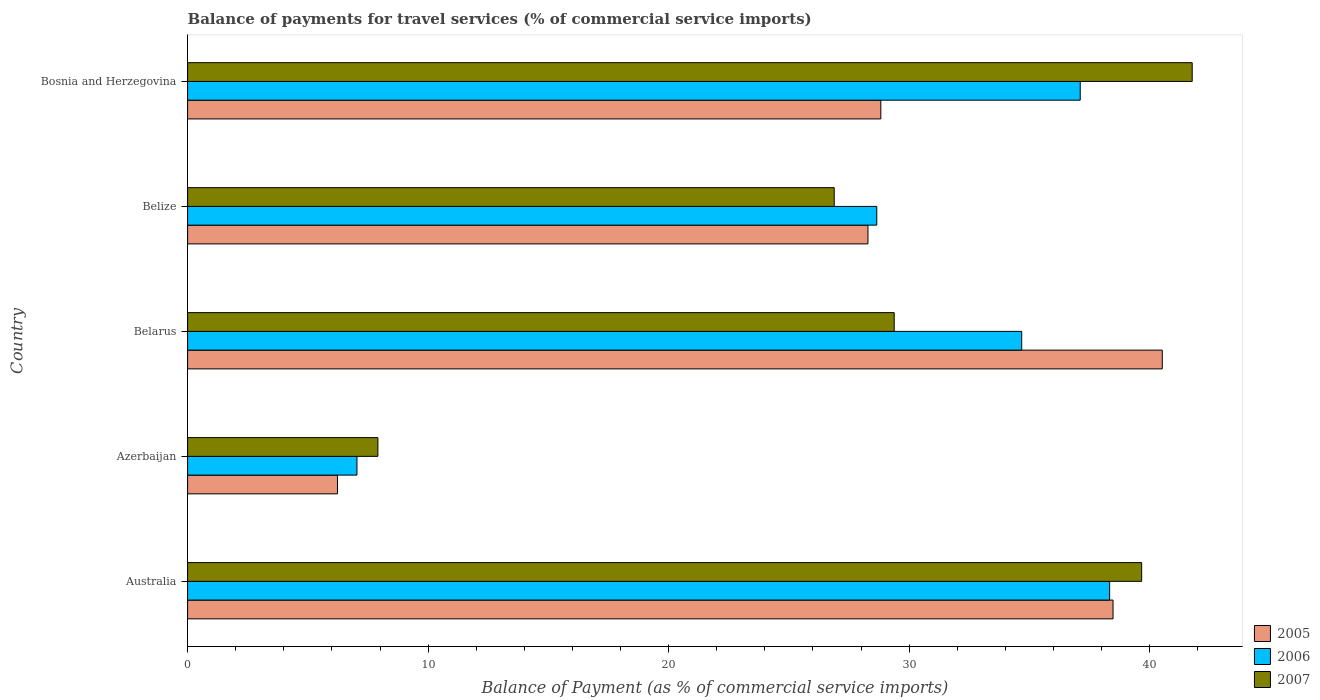How many different coloured bars are there?
Make the answer very short. 3. How many groups of bars are there?
Provide a succinct answer. 5. Are the number of bars on each tick of the Y-axis equal?
Give a very brief answer. Yes. How many bars are there on the 3rd tick from the top?
Your answer should be compact. 3. How many bars are there on the 4th tick from the bottom?
Provide a short and direct response. 3. What is the label of the 4th group of bars from the top?
Make the answer very short. Azerbaijan. What is the balance of payments for travel services in 2005 in Bosnia and Herzegovina?
Your answer should be compact. 28.82. Across all countries, what is the maximum balance of payments for travel services in 2006?
Keep it short and to the point. 38.34. Across all countries, what is the minimum balance of payments for travel services in 2007?
Your answer should be very brief. 7.91. In which country was the balance of payments for travel services in 2005 maximum?
Give a very brief answer. Belarus. In which country was the balance of payments for travel services in 2006 minimum?
Your response must be concise. Azerbaijan. What is the total balance of payments for travel services in 2005 in the graph?
Offer a very short reply. 142.35. What is the difference between the balance of payments for travel services in 2007 in Australia and that in Belarus?
Make the answer very short. 10.29. What is the difference between the balance of payments for travel services in 2007 in Belize and the balance of payments for travel services in 2005 in Bosnia and Herzegovina?
Your response must be concise. -1.94. What is the average balance of payments for travel services in 2005 per country?
Ensure brevity in your answer.  28.47. What is the difference between the balance of payments for travel services in 2005 and balance of payments for travel services in 2006 in Australia?
Your answer should be compact. 0.14. What is the ratio of the balance of payments for travel services in 2005 in Australia to that in Azerbaijan?
Offer a very short reply. 6.17. Is the difference between the balance of payments for travel services in 2005 in Belarus and Bosnia and Herzegovina greater than the difference between the balance of payments for travel services in 2006 in Belarus and Bosnia and Herzegovina?
Keep it short and to the point. Yes. What is the difference between the highest and the second highest balance of payments for travel services in 2006?
Offer a terse response. 1.22. What is the difference between the highest and the lowest balance of payments for travel services in 2006?
Your response must be concise. 31.3. What does the 1st bar from the top in Belarus represents?
Ensure brevity in your answer.  2007. Is it the case that in every country, the sum of the balance of payments for travel services in 2006 and balance of payments for travel services in 2005 is greater than the balance of payments for travel services in 2007?
Keep it short and to the point. Yes. How many bars are there?
Keep it short and to the point. 15. Are all the bars in the graph horizontal?
Your answer should be compact. Yes. What is the difference between two consecutive major ticks on the X-axis?
Your answer should be compact. 10. Does the graph contain grids?
Make the answer very short. No. How many legend labels are there?
Provide a succinct answer. 3. How are the legend labels stacked?
Ensure brevity in your answer.  Vertical. What is the title of the graph?
Provide a short and direct response. Balance of payments for travel services (% of commercial service imports). What is the label or title of the X-axis?
Your response must be concise. Balance of Payment (as % of commercial service imports). What is the label or title of the Y-axis?
Make the answer very short. Country. What is the Balance of Payment (as % of commercial service imports) of 2005 in Australia?
Your response must be concise. 38.48. What is the Balance of Payment (as % of commercial service imports) in 2006 in Australia?
Give a very brief answer. 38.34. What is the Balance of Payment (as % of commercial service imports) of 2007 in Australia?
Make the answer very short. 39.67. What is the Balance of Payment (as % of commercial service imports) in 2005 in Azerbaijan?
Give a very brief answer. 6.23. What is the Balance of Payment (as % of commercial service imports) of 2006 in Azerbaijan?
Your answer should be very brief. 7.04. What is the Balance of Payment (as % of commercial service imports) of 2007 in Azerbaijan?
Make the answer very short. 7.91. What is the Balance of Payment (as % of commercial service imports) in 2005 in Belarus?
Provide a short and direct response. 40.53. What is the Balance of Payment (as % of commercial service imports) of 2006 in Belarus?
Your answer should be compact. 34.68. What is the Balance of Payment (as % of commercial service imports) of 2007 in Belarus?
Ensure brevity in your answer.  29.38. What is the Balance of Payment (as % of commercial service imports) of 2005 in Belize?
Give a very brief answer. 28.29. What is the Balance of Payment (as % of commercial service imports) in 2006 in Belize?
Make the answer very short. 28.66. What is the Balance of Payment (as % of commercial service imports) in 2007 in Belize?
Your response must be concise. 26.89. What is the Balance of Payment (as % of commercial service imports) in 2005 in Bosnia and Herzegovina?
Give a very brief answer. 28.82. What is the Balance of Payment (as % of commercial service imports) of 2006 in Bosnia and Herzegovina?
Give a very brief answer. 37.12. What is the Balance of Payment (as % of commercial service imports) in 2007 in Bosnia and Herzegovina?
Give a very brief answer. 41.77. Across all countries, what is the maximum Balance of Payment (as % of commercial service imports) of 2005?
Give a very brief answer. 40.53. Across all countries, what is the maximum Balance of Payment (as % of commercial service imports) of 2006?
Offer a terse response. 38.34. Across all countries, what is the maximum Balance of Payment (as % of commercial service imports) in 2007?
Your response must be concise. 41.77. Across all countries, what is the minimum Balance of Payment (as % of commercial service imports) in 2005?
Your answer should be very brief. 6.23. Across all countries, what is the minimum Balance of Payment (as % of commercial service imports) of 2006?
Provide a short and direct response. 7.04. Across all countries, what is the minimum Balance of Payment (as % of commercial service imports) in 2007?
Offer a very short reply. 7.91. What is the total Balance of Payment (as % of commercial service imports) in 2005 in the graph?
Provide a short and direct response. 142.35. What is the total Balance of Payment (as % of commercial service imports) of 2006 in the graph?
Your response must be concise. 145.83. What is the total Balance of Payment (as % of commercial service imports) of 2007 in the graph?
Your response must be concise. 145.62. What is the difference between the Balance of Payment (as % of commercial service imports) of 2005 in Australia and that in Azerbaijan?
Your answer should be compact. 32.25. What is the difference between the Balance of Payment (as % of commercial service imports) in 2006 in Australia and that in Azerbaijan?
Offer a very short reply. 31.3. What is the difference between the Balance of Payment (as % of commercial service imports) in 2007 in Australia and that in Azerbaijan?
Make the answer very short. 31.76. What is the difference between the Balance of Payment (as % of commercial service imports) in 2005 in Australia and that in Belarus?
Your answer should be very brief. -2.05. What is the difference between the Balance of Payment (as % of commercial service imports) in 2006 in Australia and that in Belarus?
Provide a short and direct response. 3.66. What is the difference between the Balance of Payment (as % of commercial service imports) in 2007 in Australia and that in Belarus?
Offer a very short reply. 10.29. What is the difference between the Balance of Payment (as % of commercial service imports) of 2005 in Australia and that in Belize?
Offer a very short reply. 10.19. What is the difference between the Balance of Payment (as % of commercial service imports) of 2006 in Australia and that in Belize?
Provide a short and direct response. 9.68. What is the difference between the Balance of Payment (as % of commercial service imports) of 2007 in Australia and that in Belize?
Offer a very short reply. 12.78. What is the difference between the Balance of Payment (as % of commercial service imports) in 2005 in Australia and that in Bosnia and Herzegovina?
Make the answer very short. 9.65. What is the difference between the Balance of Payment (as % of commercial service imports) in 2006 in Australia and that in Bosnia and Herzegovina?
Offer a very short reply. 1.22. What is the difference between the Balance of Payment (as % of commercial service imports) in 2007 in Australia and that in Bosnia and Herzegovina?
Keep it short and to the point. -2.1. What is the difference between the Balance of Payment (as % of commercial service imports) in 2005 in Azerbaijan and that in Belarus?
Give a very brief answer. -34.3. What is the difference between the Balance of Payment (as % of commercial service imports) of 2006 in Azerbaijan and that in Belarus?
Offer a terse response. -27.64. What is the difference between the Balance of Payment (as % of commercial service imports) of 2007 in Azerbaijan and that in Belarus?
Make the answer very short. -21.47. What is the difference between the Balance of Payment (as % of commercial service imports) of 2005 in Azerbaijan and that in Belize?
Offer a very short reply. -22.06. What is the difference between the Balance of Payment (as % of commercial service imports) of 2006 in Azerbaijan and that in Belize?
Your answer should be very brief. -21.61. What is the difference between the Balance of Payment (as % of commercial service imports) in 2007 in Azerbaijan and that in Belize?
Offer a terse response. -18.97. What is the difference between the Balance of Payment (as % of commercial service imports) in 2005 in Azerbaijan and that in Bosnia and Herzegovina?
Give a very brief answer. -22.59. What is the difference between the Balance of Payment (as % of commercial service imports) in 2006 in Azerbaijan and that in Bosnia and Herzegovina?
Your response must be concise. -30.07. What is the difference between the Balance of Payment (as % of commercial service imports) in 2007 in Azerbaijan and that in Bosnia and Herzegovina?
Your answer should be very brief. -33.86. What is the difference between the Balance of Payment (as % of commercial service imports) in 2005 in Belarus and that in Belize?
Provide a short and direct response. 12.24. What is the difference between the Balance of Payment (as % of commercial service imports) in 2006 in Belarus and that in Belize?
Provide a short and direct response. 6.03. What is the difference between the Balance of Payment (as % of commercial service imports) of 2007 in Belarus and that in Belize?
Provide a succinct answer. 2.49. What is the difference between the Balance of Payment (as % of commercial service imports) of 2005 in Belarus and that in Bosnia and Herzegovina?
Keep it short and to the point. 11.7. What is the difference between the Balance of Payment (as % of commercial service imports) in 2006 in Belarus and that in Bosnia and Herzegovina?
Make the answer very short. -2.43. What is the difference between the Balance of Payment (as % of commercial service imports) in 2007 in Belarus and that in Bosnia and Herzegovina?
Your answer should be compact. -12.39. What is the difference between the Balance of Payment (as % of commercial service imports) of 2005 in Belize and that in Bosnia and Herzegovina?
Provide a succinct answer. -0.53. What is the difference between the Balance of Payment (as % of commercial service imports) of 2006 in Belize and that in Bosnia and Herzegovina?
Offer a very short reply. -8.46. What is the difference between the Balance of Payment (as % of commercial service imports) of 2007 in Belize and that in Bosnia and Herzegovina?
Ensure brevity in your answer.  -14.88. What is the difference between the Balance of Payment (as % of commercial service imports) of 2005 in Australia and the Balance of Payment (as % of commercial service imports) of 2006 in Azerbaijan?
Give a very brief answer. 31.44. What is the difference between the Balance of Payment (as % of commercial service imports) of 2005 in Australia and the Balance of Payment (as % of commercial service imports) of 2007 in Azerbaijan?
Give a very brief answer. 30.57. What is the difference between the Balance of Payment (as % of commercial service imports) of 2006 in Australia and the Balance of Payment (as % of commercial service imports) of 2007 in Azerbaijan?
Make the answer very short. 30.43. What is the difference between the Balance of Payment (as % of commercial service imports) in 2005 in Australia and the Balance of Payment (as % of commercial service imports) in 2006 in Belarus?
Your answer should be compact. 3.8. What is the difference between the Balance of Payment (as % of commercial service imports) of 2005 in Australia and the Balance of Payment (as % of commercial service imports) of 2007 in Belarus?
Make the answer very short. 9.1. What is the difference between the Balance of Payment (as % of commercial service imports) of 2006 in Australia and the Balance of Payment (as % of commercial service imports) of 2007 in Belarus?
Keep it short and to the point. 8.96. What is the difference between the Balance of Payment (as % of commercial service imports) of 2005 in Australia and the Balance of Payment (as % of commercial service imports) of 2006 in Belize?
Your answer should be compact. 9.82. What is the difference between the Balance of Payment (as % of commercial service imports) in 2005 in Australia and the Balance of Payment (as % of commercial service imports) in 2007 in Belize?
Provide a short and direct response. 11.59. What is the difference between the Balance of Payment (as % of commercial service imports) in 2006 in Australia and the Balance of Payment (as % of commercial service imports) in 2007 in Belize?
Provide a succinct answer. 11.45. What is the difference between the Balance of Payment (as % of commercial service imports) in 2005 in Australia and the Balance of Payment (as % of commercial service imports) in 2006 in Bosnia and Herzegovina?
Give a very brief answer. 1.36. What is the difference between the Balance of Payment (as % of commercial service imports) in 2005 in Australia and the Balance of Payment (as % of commercial service imports) in 2007 in Bosnia and Herzegovina?
Provide a succinct answer. -3.29. What is the difference between the Balance of Payment (as % of commercial service imports) in 2006 in Australia and the Balance of Payment (as % of commercial service imports) in 2007 in Bosnia and Herzegovina?
Your answer should be compact. -3.43. What is the difference between the Balance of Payment (as % of commercial service imports) of 2005 in Azerbaijan and the Balance of Payment (as % of commercial service imports) of 2006 in Belarus?
Your response must be concise. -28.45. What is the difference between the Balance of Payment (as % of commercial service imports) in 2005 in Azerbaijan and the Balance of Payment (as % of commercial service imports) in 2007 in Belarus?
Ensure brevity in your answer.  -23.15. What is the difference between the Balance of Payment (as % of commercial service imports) in 2006 in Azerbaijan and the Balance of Payment (as % of commercial service imports) in 2007 in Belarus?
Ensure brevity in your answer.  -22.34. What is the difference between the Balance of Payment (as % of commercial service imports) in 2005 in Azerbaijan and the Balance of Payment (as % of commercial service imports) in 2006 in Belize?
Give a very brief answer. -22.42. What is the difference between the Balance of Payment (as % of commercial service imports) in 2005 in Azerbaijan and the Balance of Payment (as % of commercial service imports) in 2007 in Belize?
Your response must be concise. -20.65. What is the difference between the Balance of Payment (as % of commercial service imports) in 2006 in Azerbaijan and the Balance of Payment (as % of commercial service imports) in 2007 in Belize?
Your answer should be very brief. -19.84. What is the difference between the Balance of Payment (as % of commercial service imports) in 2005 in Azerbaijan and the Balance of Payment (as % of commercial service imports) in 2006 in Bosnia and Herzegovina?
Keep it short and to the point. -30.88. What is the difference between the Balance of Payment (as % of commercial service imports) of 2005 in Azerbaijan and the Balance of Payment (as % of commercial service imports) of 2007 in Bosnia and Herzegovina?
Provide a short and direct response. -35.54. What is the difference between the Balance of Payment (as % of commercial service imports) in 2006 in Azerbaijan and the Balance of Payment (as % of commercial service imports) in 2007 in Bosnia and Herzegovina?
Provide a succinct answer. -34.73. What is the difference between the Balance of Payment (as % of commercial service imports) in 2005 in Belarus and the Balance of Payment (as % of commercial service imports) in 2006 in Belize?
Offer a very short reply. 11.87. What is the difference between the Balance of Payment (as % of commercial service imports) in 2005 in Belarus and the Balance of Payment (as % of commercial service imports) in 2007 in Belize?
Give a very brief answer. 13.64. What is the difference between the Balance of Payment (as % of commercial service imports) of 2006 in Belarus and the Balance of Payment (as % of commercial service imports) of 2007 in Belize?
Give a very brief answer. 7.8. What is the difference between the Balance of Payment (as % of commercial service imports) of 2005 in Belarus and the Balance of Payment (as % of commercial service imports) of 2006 in Bosnia and Herzegovina?
Keep it short and to the point. 3.41. What is the difference between the Balance of Payment (as % of commercial service imports) in 2005 in Belarus and the Balance of Payment (as % of commercial service imports) in 2007 in Bosnia and Herzegovina?
Ensure brevity in your answer.  -1.24. What is the difference between the Balance of Payment (as % of commercial service imports) of 2006 in Belarus and the Balance of Payment (as % of commercial service imports) of 2007 in Bosnia and Herzegovina?
Provide a succinct answer. -7.09. What is the difference between the Balance of Payment (as % of commercial service imports) of 2005 in Belize and the Balance of Payment (as % of commercial service imports) of 2006 in Bosnia and Herzegovina?
Offer a very short reply. -8.83. What is the difference between the Balance of Payment (as % of commercial service imports) of 2005 in Belize and the Balance of Payment (as % of commercial service imports) of 2007 in Bosnia and Herzegovina?
Make the answer very short. -13.48. What is the difference between the Balance of Payment (as % of commercial service imports) of 2006 in Belize and the Balance of Payment (as % of commercial service imports) of 2007 in Bosnia and Herzegovina?
Make the answer very short. -13.12. What is the average Balance of Payment (as % of commercial service imports) in 2005 per country?
Your answer should be compact. 28.47. What is the average Balance of Payment (as % of commercial service imports) of 2006 per country?
Your answer should be very brief. 29.17. What is the average Balance of Payment (as % of commercial service imports) of 2007 per country?
Offer a very short reply. 29.12. What is the difference between the Balance of Payment (as % of commercial service imports) in 2005 and Balance of Payment (as % of commercial service imports) in 2006 in Australia?
Ensure brevity in your answer.  0.14. What is the difference between the Balance of Payment (as % of commercial service imports) of 2005 and Balance of Payment (as % of commercial service imports) of 2007 in Australia?
Keep it short and to the point. -1.19. What is the difference between the Balance of Payment (as % of commercial service imports) of 2006 and Balance of Payment (as % of commercial service imports) of 2007 in Australia?
Your answer should be very brief. -1.33. What is the difference between the Balance of Payment (as % of commercial service imports) of 2005 and Balance of Payment (as % of commercial service imports) of 2006 in Azerbaijan?
Your answer should be compact. -0.81. What is the difference between the Balance of Payment (as % of commercial service imports) of 2005 and Balance of Payment (as % of commercial service imports) of 2007 in Azerbaijan?
Offer a terse response. -1.68. What is the difference between the Balance of Payment (as % of commercial service imports) of 2006 and Balance of Payment (as % of commercial service imports) of 2007 in Azerbaijan?
Keep it short and to the point. -0.87. What is the difference between the Balance of Payment (as % of commercial service imports) of 2005 and Balance of Payment (as % of commercial service imports) of 2006 in Belarus?
Your response must be concise. 5.85. What is the difference between the Balance of Payment (as % of commercial service imports) of 2005 and Balance of Payment (as % of commercial service imports) of 2007 in Belarus?
Offer a terse response. 11.15. What is the difference between the Balance of Payment (as % of commercial service imports) in 2006 and Balance of Payment (as % of commercial service imports) in 2007 in Belarus?
Offer a terse response. 5.3. What is the difference between the Balance of Payment (as % of commercial service imports) in 2005 and Balance of Payment (as % of commercial service imports) in 2006 in Belize?
Make the answer very short. -0.37. What is the difference between the Balance of Payment (as % of commercial service imports) in 2005 and Balance of Payment (as % of commercial service imports) in 2007 in Belize?
Offer a terse response. 1.4. What is the difference between the Balance of Payment (as % of commercial service imports) in 2006 and Balance of Payment (as % of commercial service imports) in 2007 in Belize?
Give a very brief answer. 1.77. What is the difference between the Balance of Payment (as % of commercial service imports) of 2005 and Balance of Payment (as % of commercial service imports) of 2006 in Bosnia and Herzegovina?
Provide a succinct answer. -8.29. What is the difference between the Balance of Payment (as % of commercial service imports) of 2005 and Balance of Payment (as % of commercial service imports) of 2007 in Bosnia and Herzegovina?
Make the answer very short. -12.95. What is the difference between the Balance of Payment (as % of commercial service imports) in 2006 and Balance of Payment (as % of commercial service imports) in 2007 in Bosnia and Herzegovina?
Offer a very short reply. -4.66. What is the ratio of the Balance of Payment (as % of commercial service imports) of 2005 in Australia to that in Azerbaijan?
Provide a succinct answer. 6.17. What is the ratio of the Balance of Payment (as % of commercial service imports) of 2006 in Australia to that in Azerbaijan?
Provide a succinct answer. 5.44. What is the ratio of the Balance of Payment (as % of commercial service imports) of 2007 in Australia to that in Azerbaijan?
Provide a succinct answer. 5.01. What is the ratio of the Balance of Payment (as % of commercial service imports) of 2005 in Australia to that in Belarus?
Your response must be concise. 0.95. What is the ratio of the Balance of Payment (as % of commercial service imports) of 2006 in Australia to that in Belarus?
Offer a terse response. 1.11. What is the ratio of the Balance of Payment (as % of commercial service imports) in 2007 in Australia to that in Belarus?
Your answer should be very brief. 1.35. What is the ratio of the Balance of Payment (as % of commercial service imports) of 2005 in Australia to that in Belize?
Ensure brevity in your answer.  1.36. What is the ratio of the Balance of Payment (as % of commercial service imports) in 2006 in Australia to that in Belize?
Your answer should be compact. 1.34. What is the ratio of the Balance of Payment (as % of commercial service imports) in 2007 in Australia to that in Belize?
Your answer should be very brief. 1.48. What is the ratio of the Balance of Payment (as % of commercial service imports) of 2005 in Australia to that in Bosnia and Herzegovina?
Keep it short and to the point. 1.33. What is the ratio of the Balance of Payment (as % of commercial service imports) of 2006 in Australia to that in Bosnia and Herzegovina?
Keep it short and to the point. 1.03. What is the ratio of the Balance of Payment (as % of commercial service imports) of 2007 in Australia to that in Bosnia and Herzegovina?
Offer a terse response. 0.95. What is the ratio of the Balance of Payment (as % of commercial service imports) of 2005 in Azerbaijan to that in Belarus?
Ensure brevity in your answer.  0.15. What is the ratio of the Balance of Payment (as % of commercial service imports) in 2006 in Azerbaijan to that in Belarus?
Provide a short and direct response. 0.2. What is the ratio of the Balance of Payment (as % of commercial service imports) of 2007 in Azerbaijan to that in Belarus?
Your answer should be very brief. 0.27. What is the ratio of the Balance of Payment (as % of commercial service imports) in 2005 in Azerbaijan to that in Belize?
Keep it short and to the point. 0.22. What is the ratio of the Balance of Payment (as % of commercial service imports) in 2006 in Azerbaijan to that in Belize?
Offer a terse response. 0.25. What is the ratio of the Balance of Payment (as % of commercial service imports) of 2007 in Azerbaijan to that in Belize?
Your response must be concise. 0.29. What is the ratio of the Balance of Payment (as % of commercial service imports) of 2005 in Azerbaijan to that in Bosnia and Herzegovina?
Offer a terse response. 0.22. What is the ratio of the Balance of Payment (as % of commercial service imports) in 2006 in Azerbaijan to that in Bosnia and Herzegovina?
Give a very brief answer. 0.19. What is the ratio of the Balance of Payment (as % of commercial service imports) of 2007 in Azerbaijan to that in Bosnia and Herzegovina?
Your answer should be compact. 0.19. What is the ratio of the Balance of Payment (as % of commercial service imports) in 2005 in Belarus to that in Belize?
Provide a short and direct response. 1.43. What is the ratio of the Balance of Payment (as % of commercial service imports) in 2006 in Belarus to that in Belize?
Ensure brevity in your answer.  1.21. What is the ratio of the Balance of Payment (as % of commercial service imports) in 2007 in Belarus to that in Belize?
Offer a terse response. 1.09. What is the ratio of the Balance of Payment (as % of commercial service imports) in 2005 in Belarus to that in Bosnia and Herzegovina?
Give a very brief answer. 1.41. What is the ratio of the Balance of Payment (as % of commercial service imports) in 2006 in Belarus to that in Bosnia and Herzegovina?
Ensure brevity in your answer.  0.93. What is the ratio of the Balance of Payment (as % of commercial service imports) in 2007 in Belarus to that in Bosnia and Herzegovina?
Your answer should be compact. 0.7. What is the ratio of the Balance of Payment (as % of commercial service imports) of 2005 in Belize to that in Bosnia and Herzegovina?
Make the answer very short. 0.98. What is the ratio of the Balance of Payment (as % of commercial service imports) of 2006 in Belize to that in Bosnia and Herzegovina?
Ensure brevity in your answer.  0.77. What is the ratio of the Balance of Payment (as % of commercial service imports) of 2007 in Belize to that in Bosnia and Herzegovina?
Your answer should be compact. 0.64. What is the difference between the highest and the second highest Balance of Payment (as % of commercial service imports) in 2005?
Keep it short and to the point. 2.05. What is the difference between the highest and the second highest Balance of Payment (as % of commercial service imports) in 2006?
Provide a succinct answer. 1.22. What is the difference between the highest and the second highest Balance of Payment (as % of commercial service imports) of 2007?
Your response must be concise. 2.1. What is the difference between the highest and the lowest Balance of Payment (as % of commercial service imports) in 2005?
Your response must be concise. 34.3. What is the difference between the highest and the lowest Balance of Payment (as % of commercial service imports) of 2006?
Provide a short and direct response. 31.3. What is the difference between the highest and the lowest Balance of Payment (as % of commercial service imports) of 2007?
Provide a succinct answer. 33.86. 